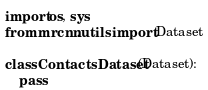Convert code to text. <code><loc_0><loc_0><loc_500><loc_500><_Python_>import os, sys
from mrcnn.utils import Dataset

class ContactsDataset(Dataset):
    pass</code> 